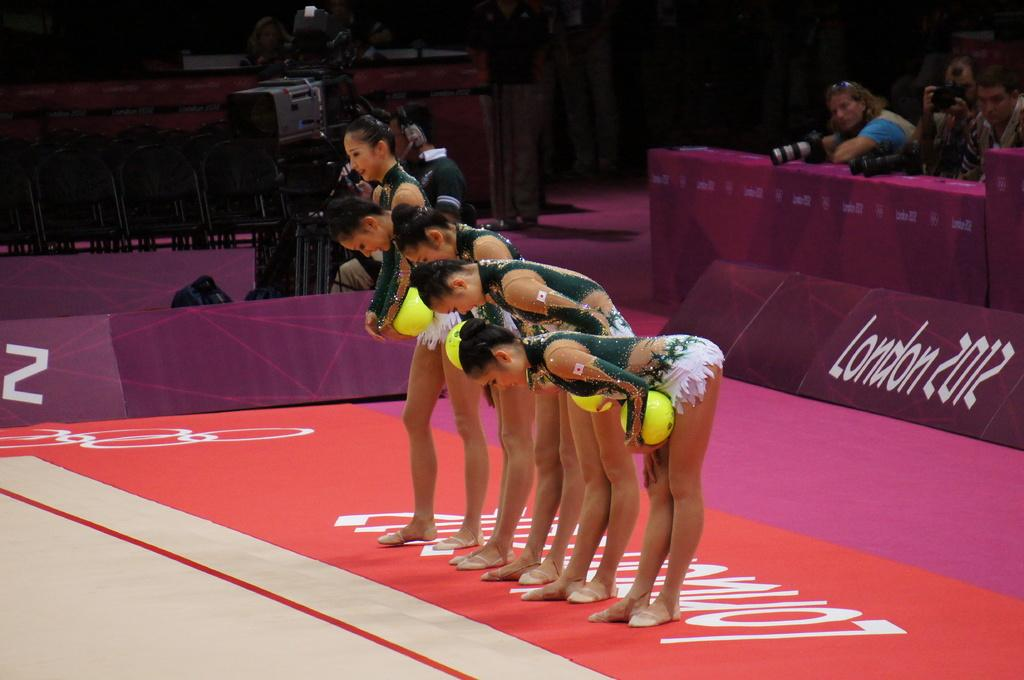<image>
Relay a brief, clear account of the picture shown. A team of women are taking a bow in London in 2012. 